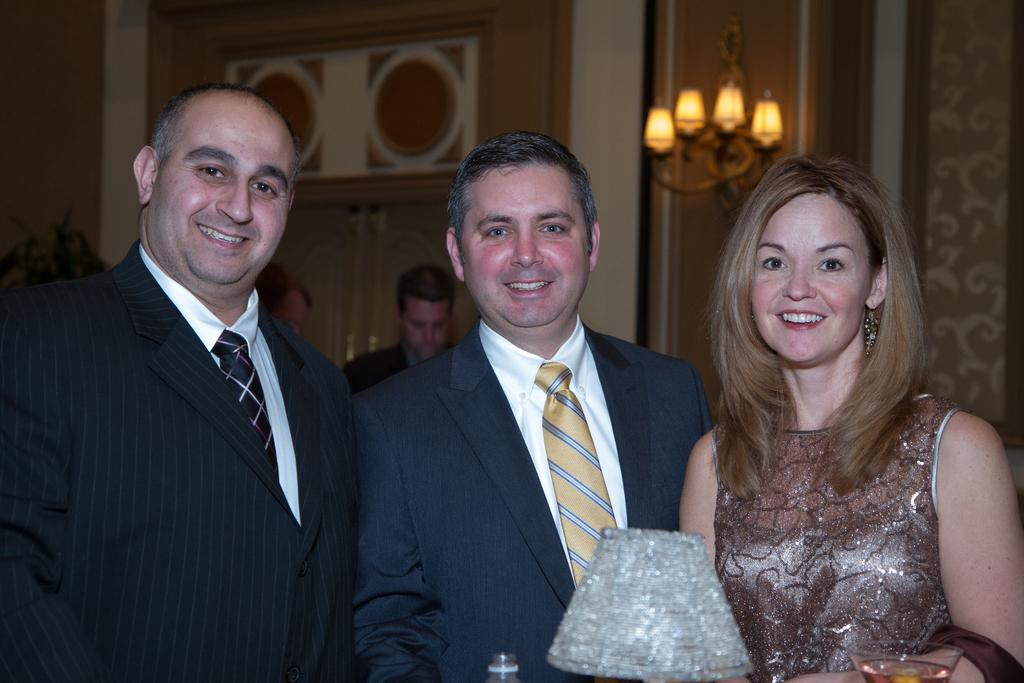What are the people in the image doing? There are persons standing in the image, and some of them are smiling. What can be seen in the background of the image? There are walls, a chandelier, a disposal bottle, and a glass tumbler with beverage in the background of the image. How many girls are sitting on the edge of the chandelier in the image? There are no girls sitting on the edge of the chandelier in the image, as there are no girls or chandelier edges mentioned in the facts. 